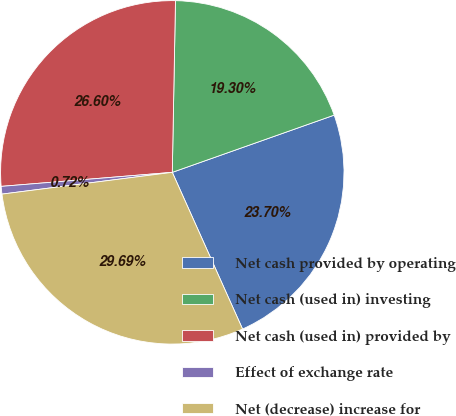<chart> <loc_0><loc_0><loc_500><loc_500><pie_chart><fcel>Net cash provided by operating<fcel>Net cash (used in) investing<fcel>Net cash (used in) provided by<fcel>Effect of exchange rate<fcel>Net (decrease) increase for<nl><fcel>23.7%<fcel>19.3%<fcel>26.6%<fcel>0.72%<fcel>29.69%<nl></chart> 